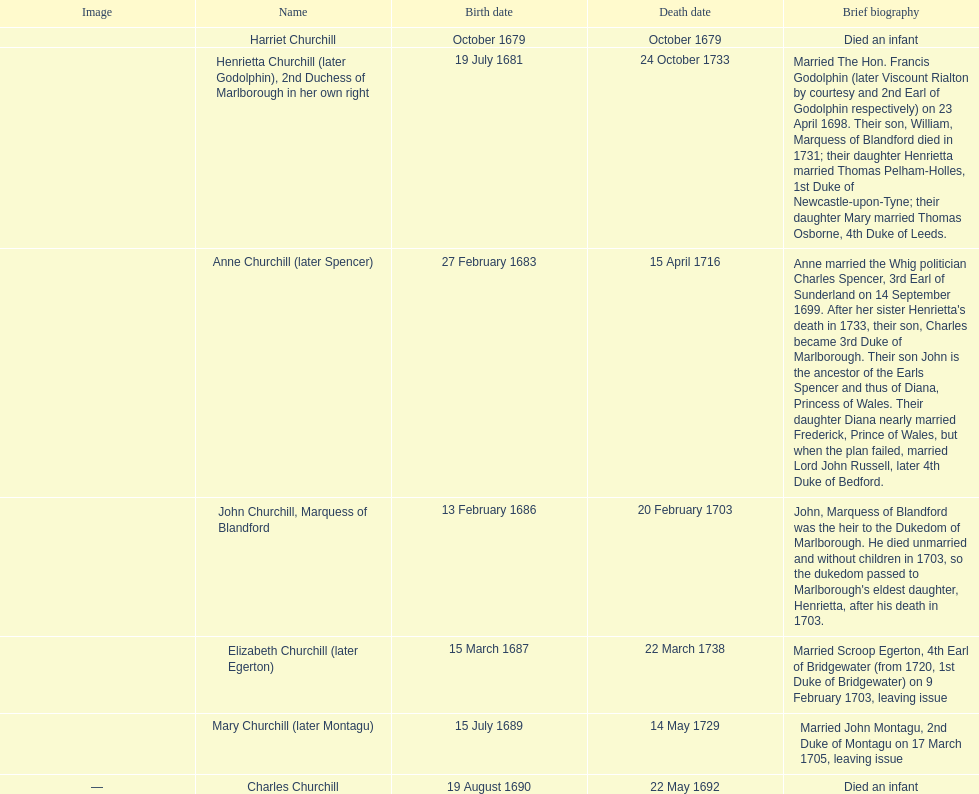What's the overall count of children on the list? 7. 